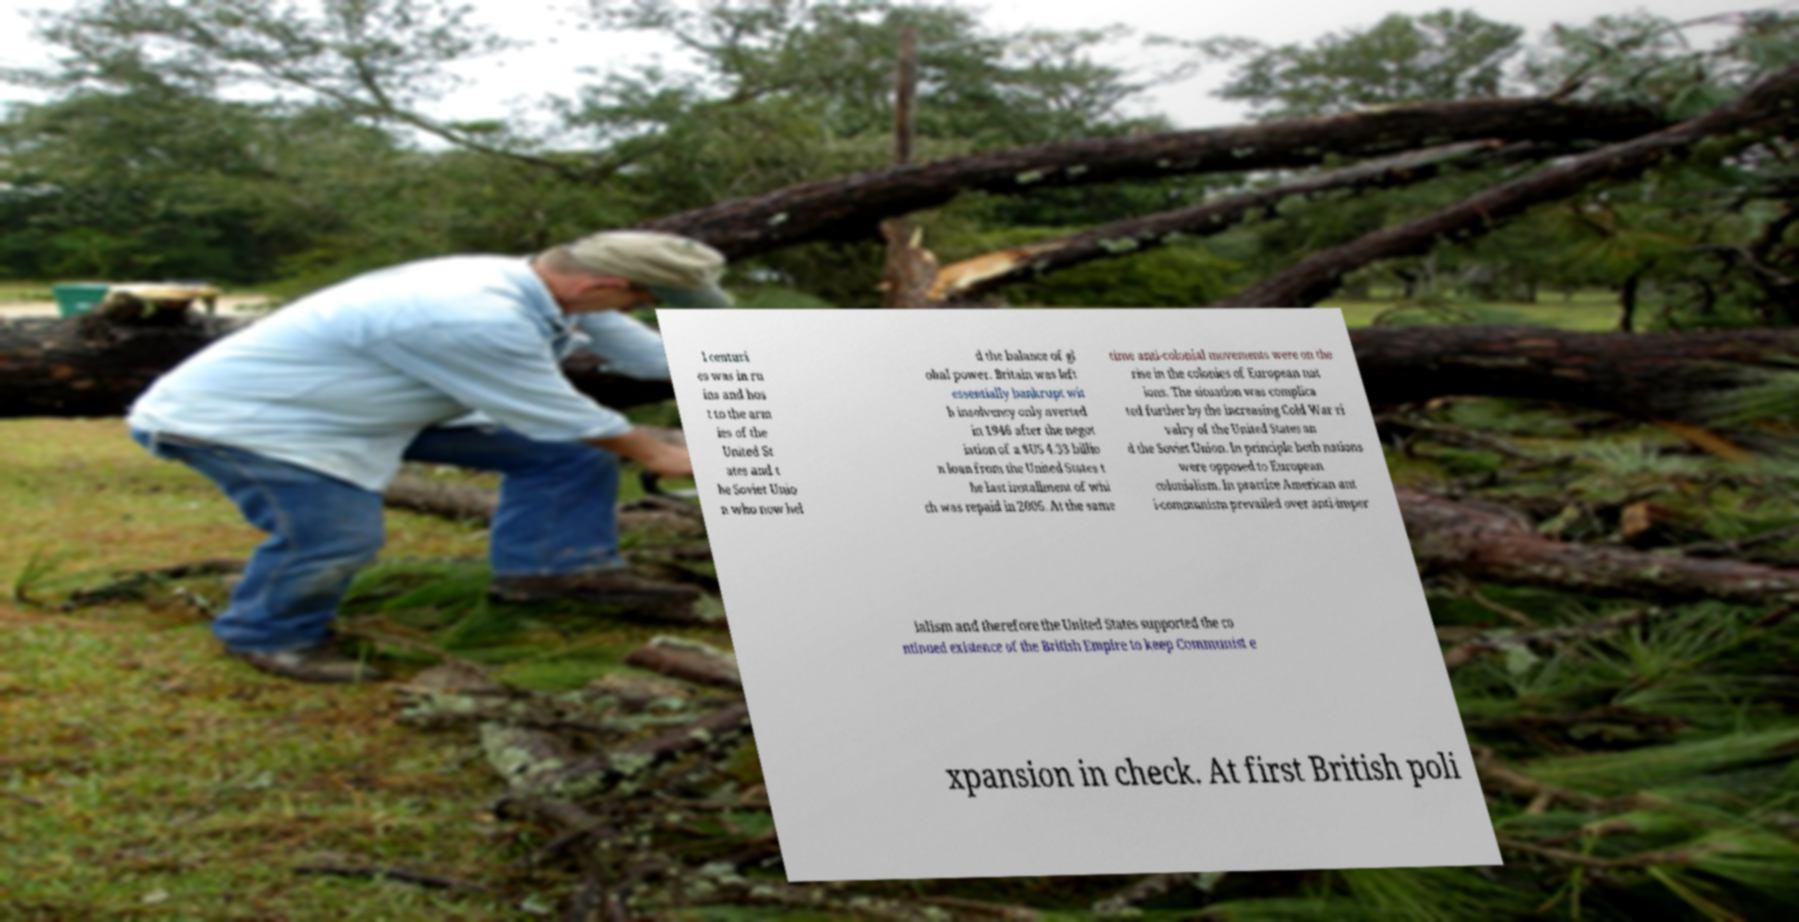Please identify and transcribe the text found in this image. l centuri es was in ru ins and hos t to the arm ies of the United St ates and t he Soviet Unio n who now hel d the balance of gl obal power. Britain was left essentially bankrupt wit h insolvency only averted in 1946 after the negot iation of a $US 4.33 billio n loan from the United States t he last installment of whi ch was repaid in 2006. At the same time anti-colonial movements were on the rise in the colonies of European nat ions. The situation was complica ted further by the increasing Cold War ri valry of the United States an d the Soviet Union. In principle both nations were opposed to European colonialism. In practice American ant i-communism prevailed over anti-imper ialism and therefore the United States supported the co ntinued existence of the British Empire to keep Communist e xpansion in check. At first British poli 